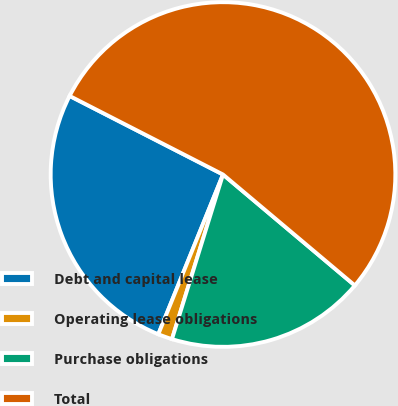Convert chart. <chart><loc_0><loc_0><loc_500><loc_500><pie_chart><fcel>Debt and capital lease<fcel>Operating lease obligations<fcel>Purchase obligations<fcel>Total<nl><fcel>26.41%<fcel>1.34%<fcel>18.65%<fcel>53.6%<nl></chart> 